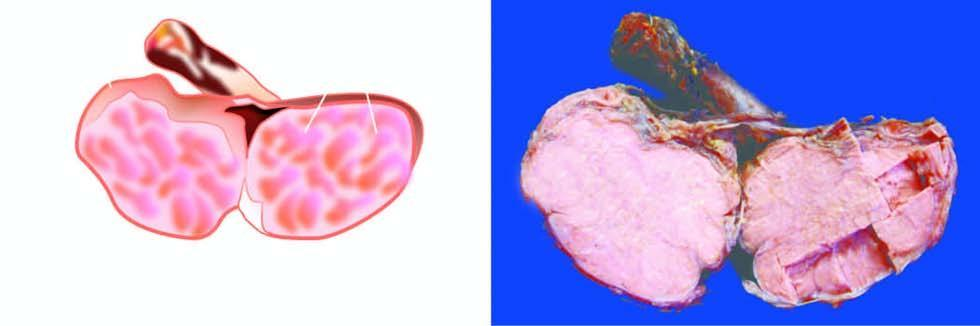s the testis enlarged but without distorting its contour?
Answer the question using a single word or phrase. Yes 